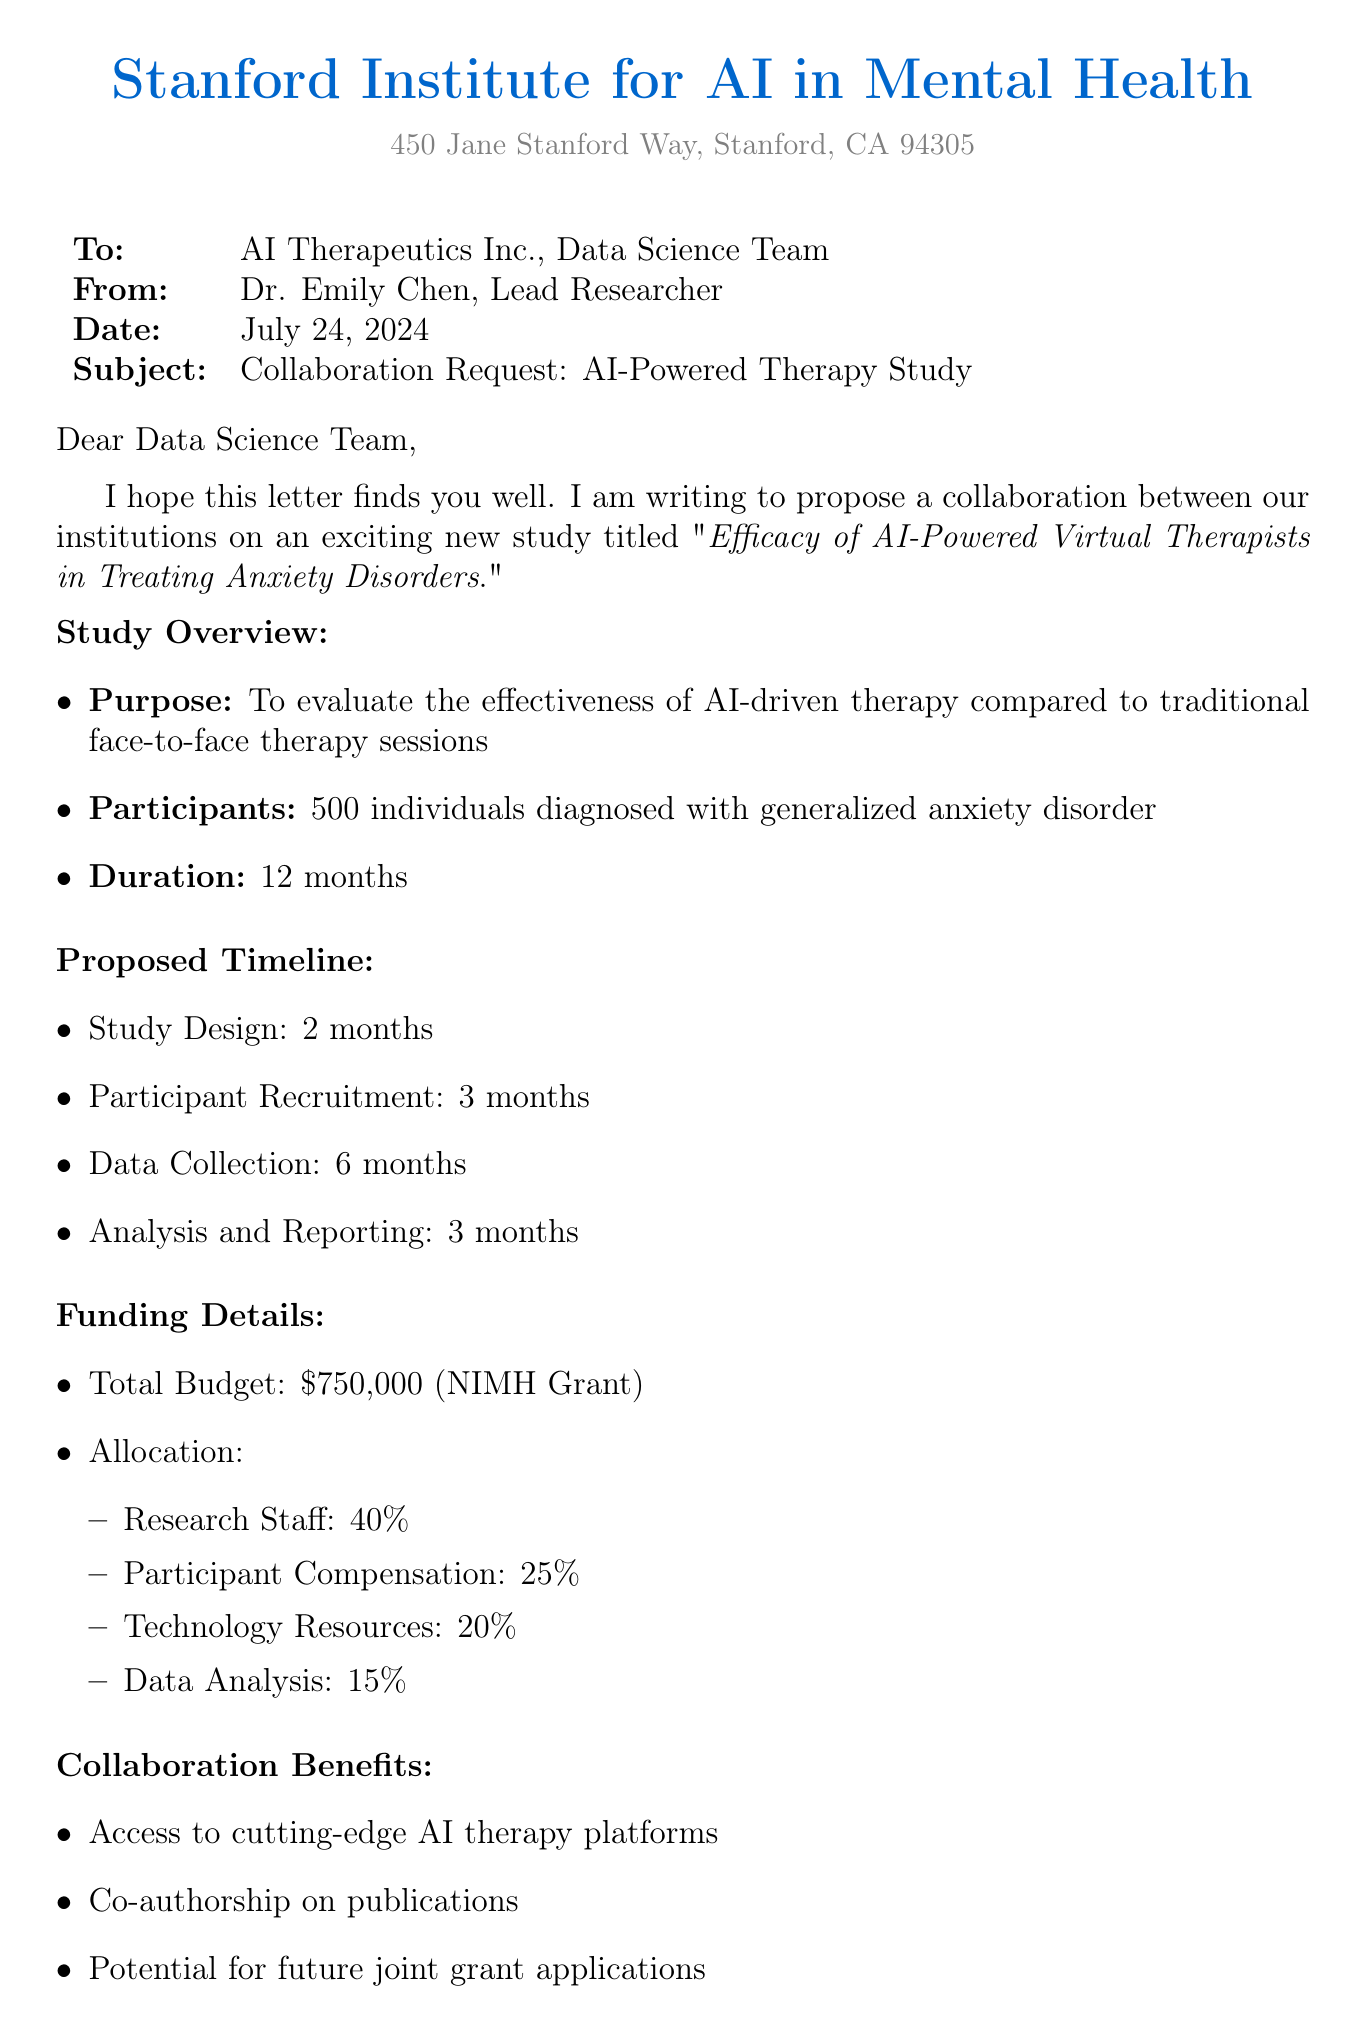What is the study title? The study title is explicitly mentioned in the document as part of the collaboration request.
Answer: Efficacy of AI-Powered Virtual Therapists in Treating Anxiety Disorders Who is the lead researcher? The lead researcher is specified at the beginning of the document with their name and title.
Answer: Dr. Emily Chen How many participants are targeted for the study? The document outlines the number of individuals diagnosed with generalized anxiety disorder that the study aims to include.
Answer: 500 What is the total budget for the study? The total budget is listed under the funding details section of the document.
Answer: $750,000 What is the duration of the study? The duration of the study is provided in the collaboration request section.
Answer: 12 months What percentage of the budget is allocated to participant compensation? The specific allocation for participant compensation is mentioned in the funding details section.
Answer: 25% How long is the participant recruitment phase? The document states the time frame for this phase in the proposed timeline section.
Answer: 3 months What is the source of the funding? The document specifies where the funding for the study is coming from.
Answer: National Institute of Mental Health (NIMH) Grant What contributions are requested from AI Therapeutics Inc.? The document lists the requested contributions in a specific section.
Answer: AI therapy platform access, Technical expertise, Data sharing capabilities 